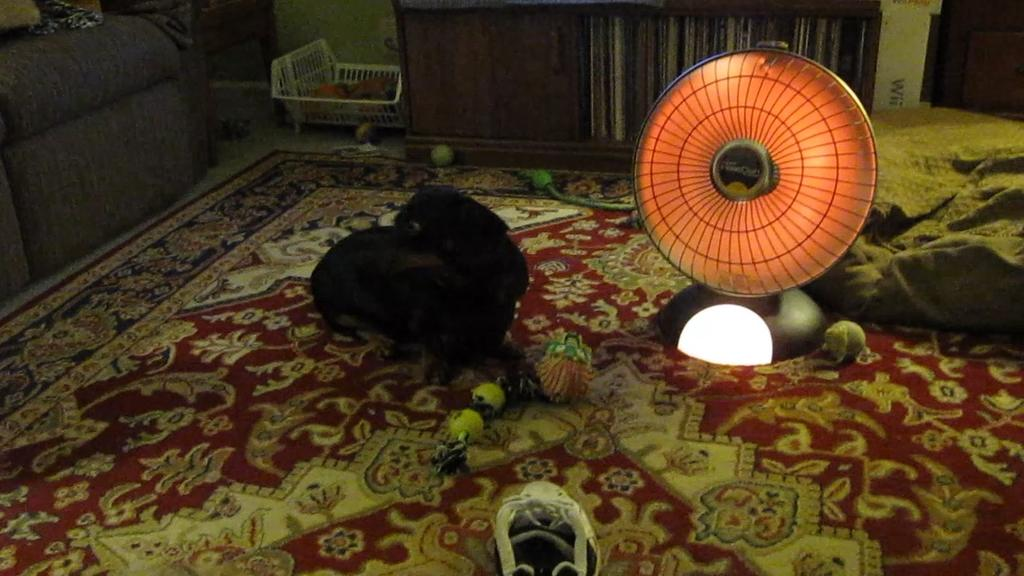What type of floor covering is visible in the image? There is a mat in the image. What type of furniture is present in the image? There is a sofa in the image. What object is used for holding or serving items in the image? There is a tray in the image. What type of storage furniture is present in the image? There are cupboards in the image. What type of appliance is present in the image? There is a table fan in the image. What type of personal items are visible in the image? There are clothes in the image. What color is the crayon used to draw on the stage in the image? There is no stage or crayon present in the image. What type of gate is visible in the image? There is no gate present in the image. 